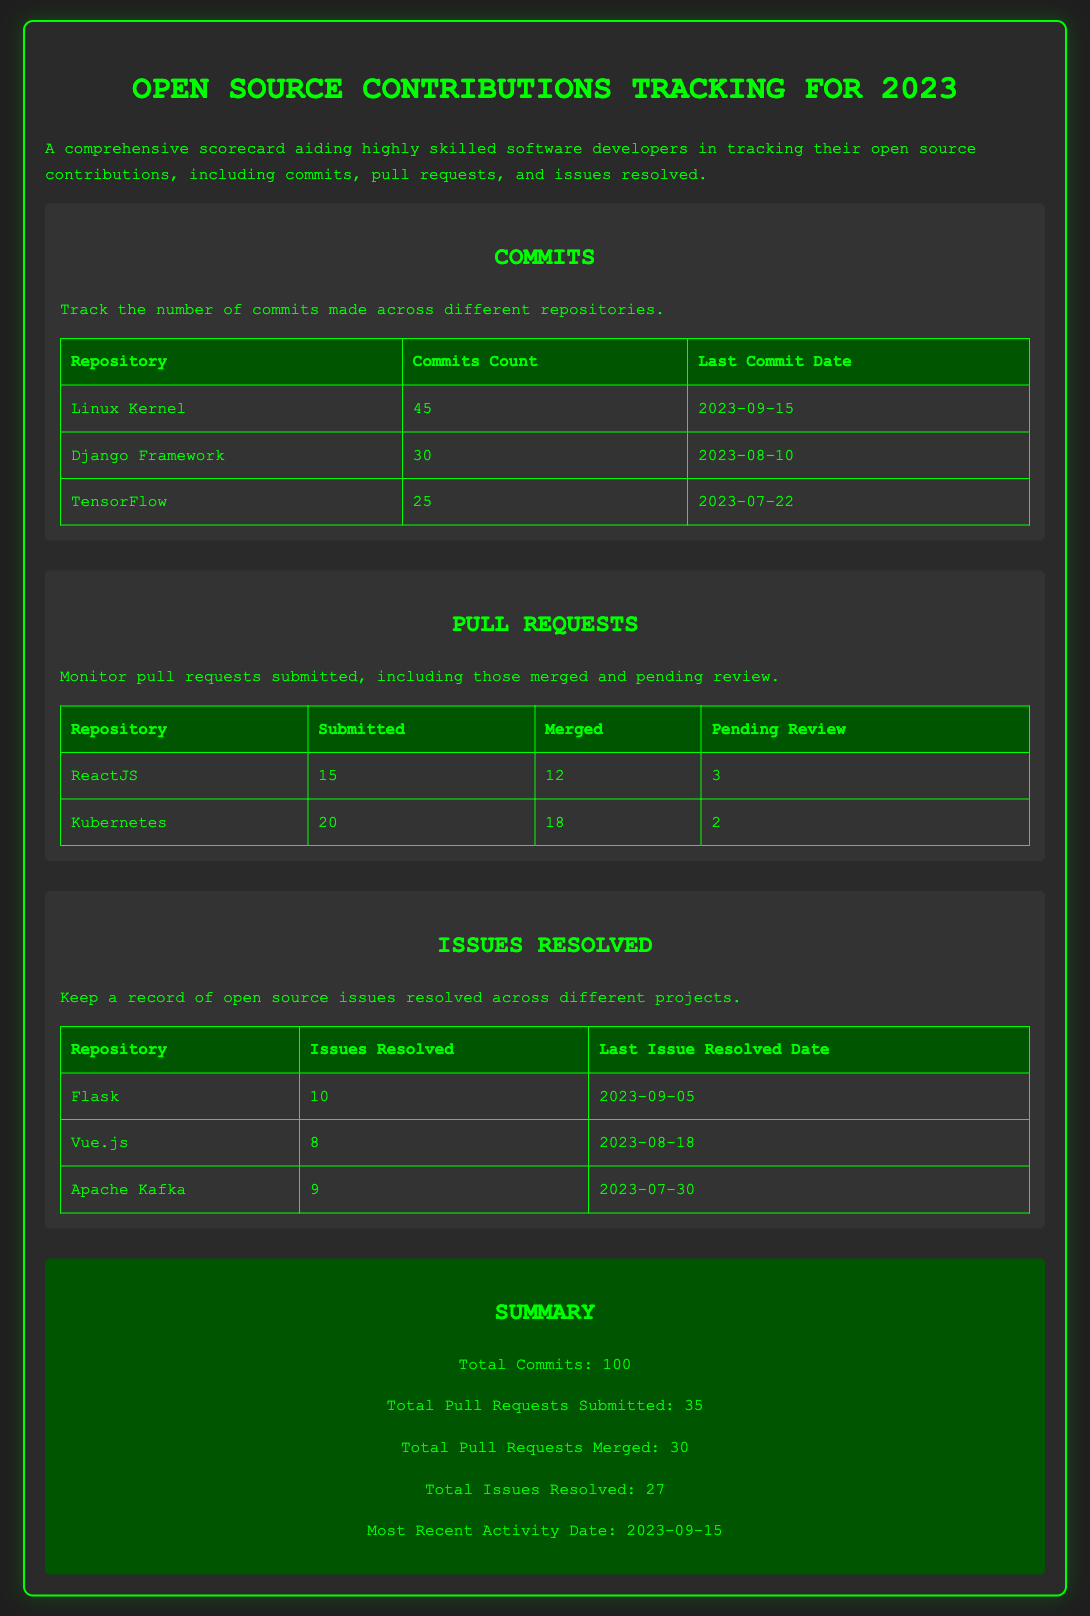What is the total number of commits? The total number of commits is summed from individual repository contributions, which is 45 + 30 + 25 = 100.
Answer: 100 Which repository had the last commit date of 2023-09-15? The repository with the last commit date of 2023-09-15 is the Linux Kernel.
Answer: Linux Kernel How many pull requests were submitted for ReactJS? The number of pull requests submitted for ReactJS is explicitly stated in the document.
Answer: 15 What is the number of issues resolved for Flask? The number of issues resolved for Flask is listed in the issues resolved section of the document.
Answer: 10 Which repository has the highest number of pull requests merged? By comparing the merged pull requests across repositories, Kubernetes has the highest count.
Answer: Kubernetes What date was the last issue resolved for Vue.js? The last issue resolved date for Vue.js is specified in the document.
Answer: 2023-08-18 How many total pull requests were merged? The total pull requests merged are calculated from the merged counts of all repositories, which is 12 + 18 = 30.
Answer: 30 What is the total number of issues resolved? The total issues resolved are summed from individual repositories, which is 10 + 8 + 9 = 27.
Answer: 27 Which repository had the most recent activity? The most recent activity date is noted in the summary section of the document.
Answer: 2023-09-15 